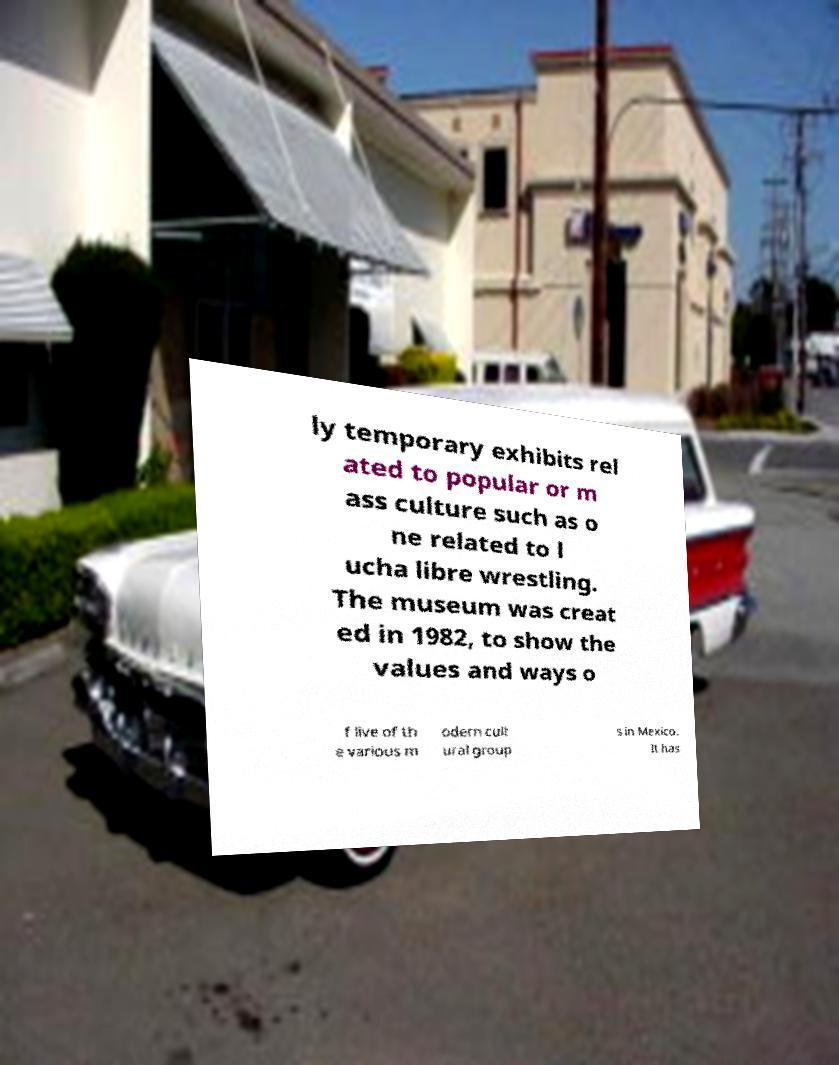I need the written content from this picture converted into text. Can you do that? ly temporary exhibits rel ated to popular or m ass culture such as o ne related to l ucha libre wrestling. The museum was creat ed in 1982, to show the values and ways o f live of th e various m odern cult ural group s in Mexico. It has 